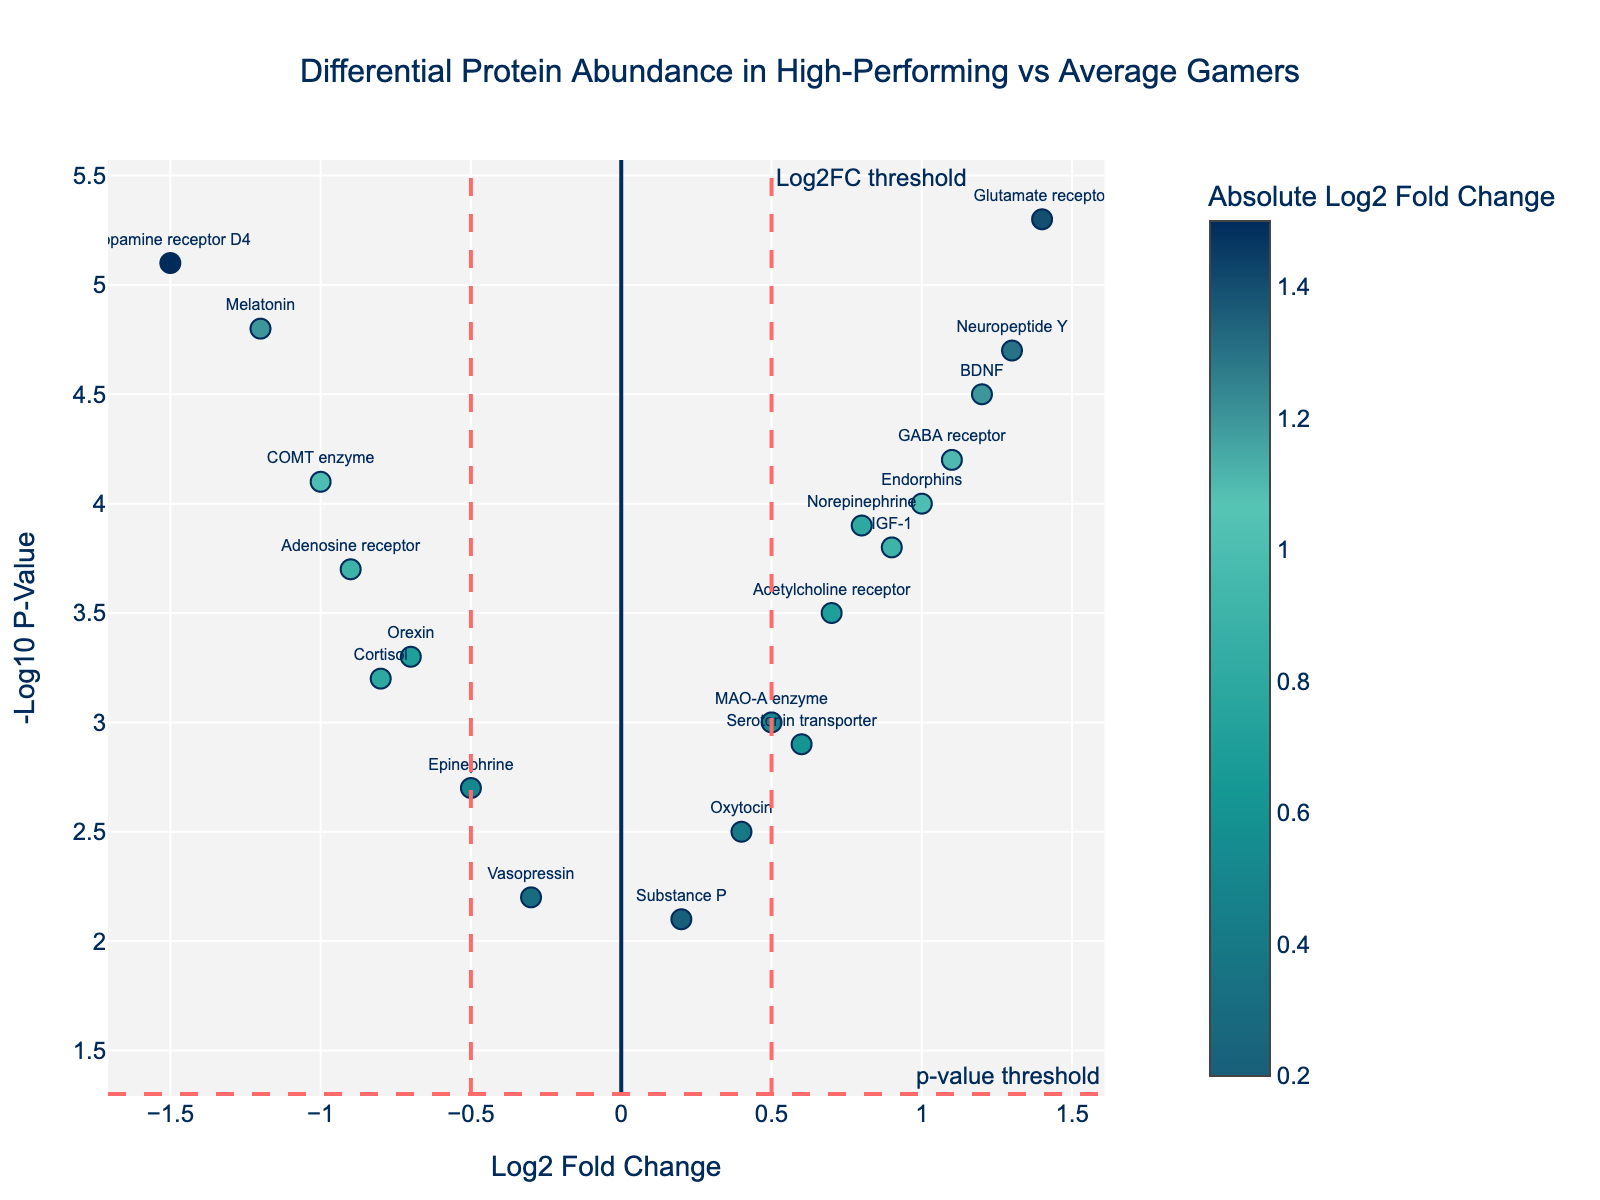What is the title of the plot? The title of the plot is displayed at the top center and reads "Differential Protein Abundance in High-Performing vs Average Gamers".
Answer: Differential Protein Abundance in High-Performing vs Average Gamers How many proteins have a log2 fold change greater than 1? To determine this, count the number of data points (proteins) with Log2 Fold Change values greater than 1. Looking at the figure, BDNF, GABA receptor, Glutamate receptor, Neuropeptide Y.
Answer: 4 Which protein has the highest negative log2 fold change value? To find the highest negative log2 fold change, locate the data point with the most negative x-axis value. The Dopamine receptor D4 protein has the lowest log2 fold change at -1.5.
Answer: Dopamine receptor D4 Which proteins exceed both the Log2FC threshold of 0.5 and the p-value threshold? To find these proteins, identify the data points where Log2 Fold Change is greater than 0.5 and Neg Log10 P-Value is greater than 1.3. These points are likely significant and include BDNF, IGF-1, GABA receptor, Norepinephrine, Glutamate receptor, Endorphins, Neuropeptide Y.
Answer: BDNF, IGF-1, GABA receptor, Norepinephrine, Glutamate receptor, Endorphins, Neuropeptide Y Which protein has the highest -log10(p-value) and what is its value? Look for the protein positioned at the highest point on the y-axis. The Glutamate receptor has the highest -log10(p-value) at 5.3.
Answer: Glutamate receptor, 5.3 Are there more proteins with positive or negative log2 fold changes? Count the number of proteins located on the right side (positive) and left side (negative) of the x-axis. There are more proteins with positive log2 fold changes.
Answer: Positive How many proteins have a -log10(p-value) greater than 4? Count the number of data points above the y-axis value of 4. The proteins are BDNF, Dopamine receptor D4, Melatonin, Glutamate receptor, Neuropeptide Y.
Answer: 5 Which protein with a negative log2 fold change has the highest significance? Among the proteins with negative log2 fold changes, find the one with the highest y-axis (Neg Log10 P-Value). Dopamine receptor D4 has a -log10(p-value) of 5.1, the highest among those with negative log2 changes.
Answer: Dopamine receptor D4 How many proteins are close to the log2FC threshold lines (within 0.1 units)? Identify proteins where Log2 Fold Change is approximately 0.5 or -0.5, specifically looking within 0.1 units. Proteins close to these thresholds include Serotonin transporter, MAO-A enzyme, Epinephrine, Norepinephrine, and Vasopressin.
Answer: 5 What is the range of log2 fold change values for all the proteins? Determine the minimum and maximum values on the x-axis to find the range. The lowest log2 fold change is -1.5 (Dopamine receptor D4) and the highest is 1.4 (Glutamate receptor), making the range -1.5 to 1.4.
Answer: -1.5 to 1.4 